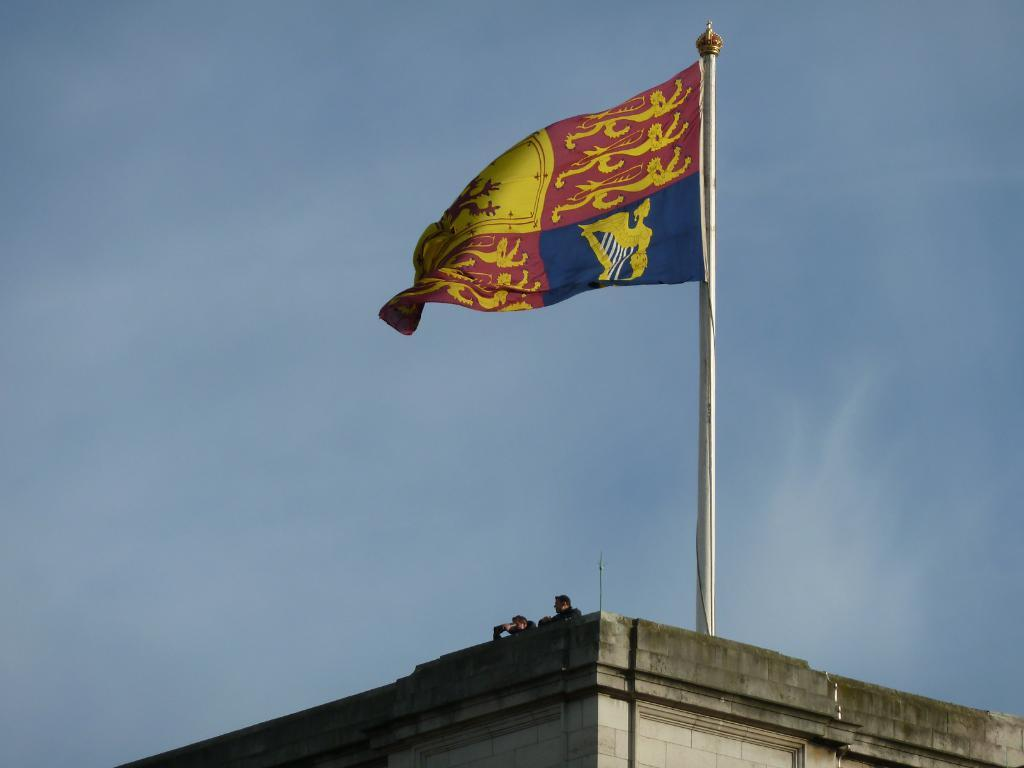How many people are in the image? There are two persons in the middle of the image. Where are the persons located? The persons are on a building. What else can be seen in the image? There is a flag in the image. How would you describe the weather in the image? The sky is cloudy in the image. What type of government is depicted in the image? There is no indication of a government in the image; it features two persons on a building, a flag, and a cloudy sky. What action is the queen performing in the image? There is no queen present in the image. 